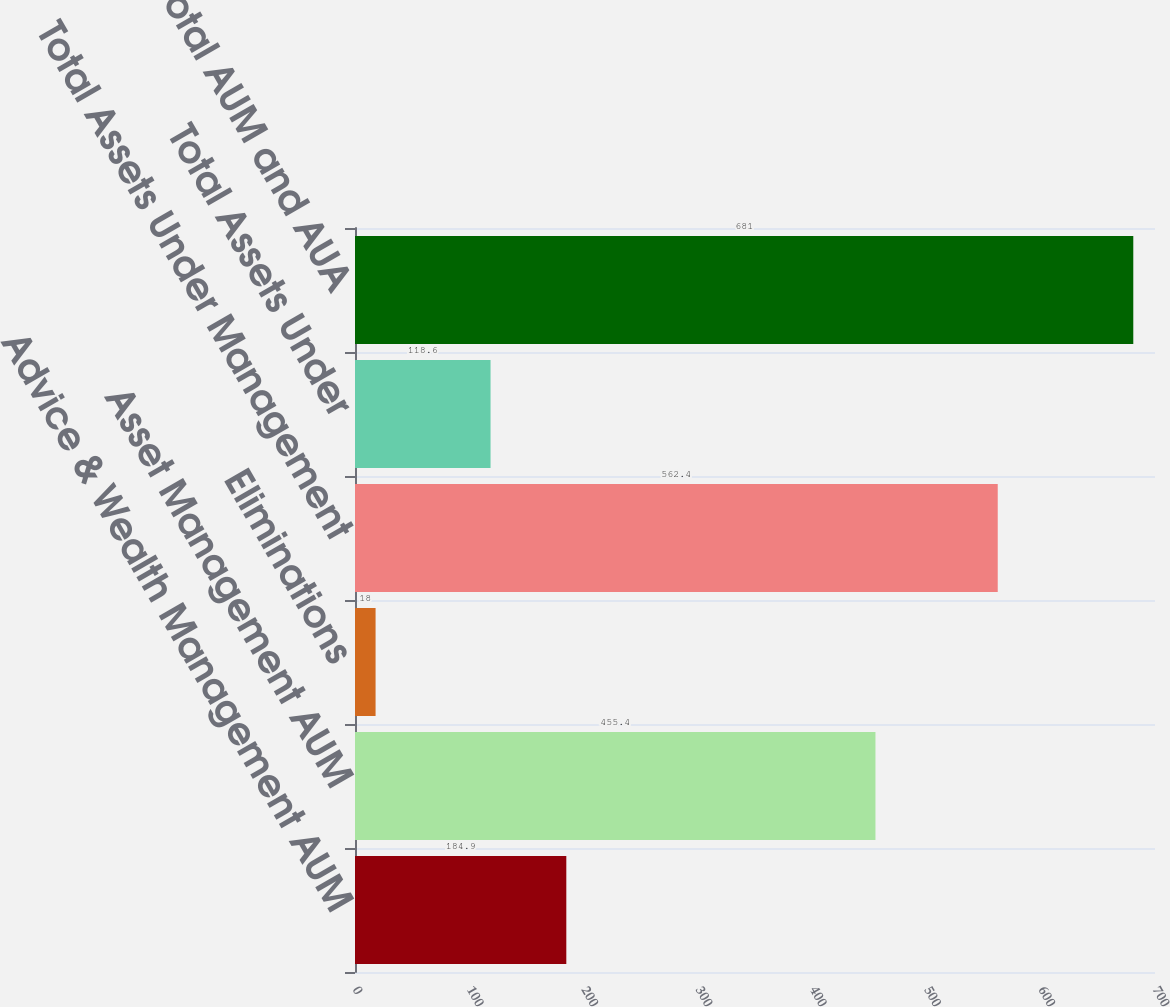Convert chart to OTSL. <chart><loc_0><loc_0><loc_500><loc_500><bar_chart><fcel>Advice & Wealth Management AUM<fcel>Asset Management AUM<fcel>Eliminations<fcel>Total Assets Under Management<fcel>Total Assets Under<fcel>Total AUM and AUA<nl><fcel>184.9<fcel>455.4<fcel>18<fcel>562.4<fcel>118.6<fcel>681<nl></chart> 